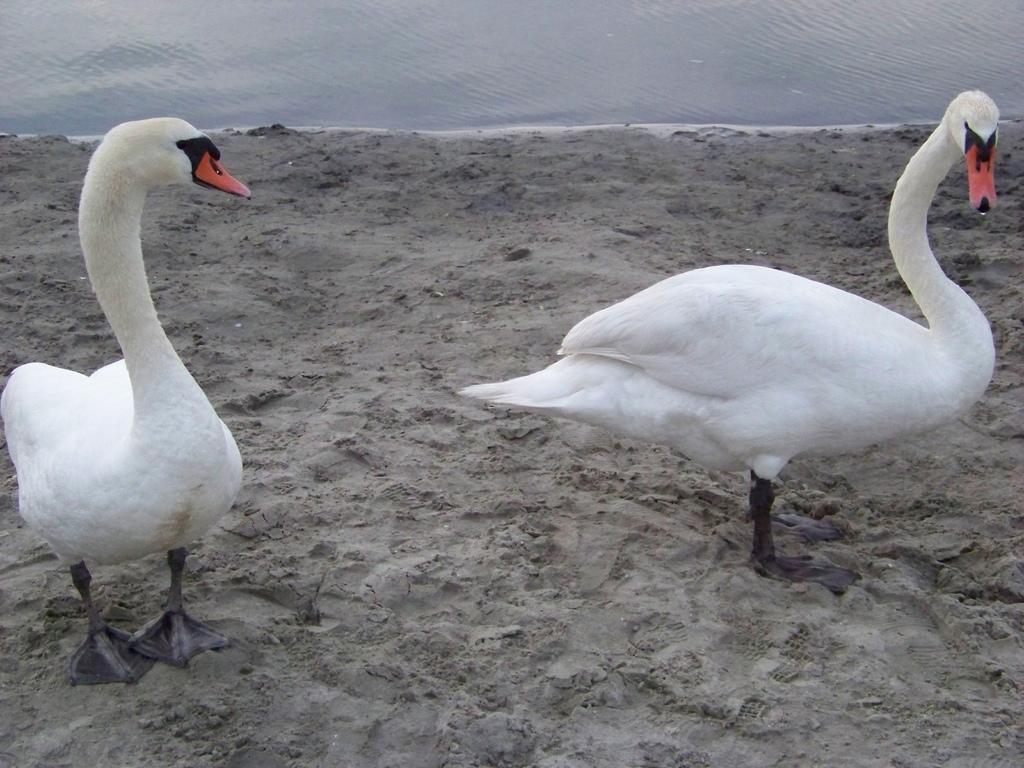What animals are in the center of the image? There are two ducks in the center of the image. What color are the ducks? The ducks are white in color. What can be seen in the background of the image? There is water and sand visible in the background of the image, along with a few other objects. How many fish can be seen swimming in the water in the image? There are no fish visible in the image; it only shows two white ducks in the center and the background elements. Can you tell me where the squirrel is hiding in the image? There is no squirrel present in the image. 